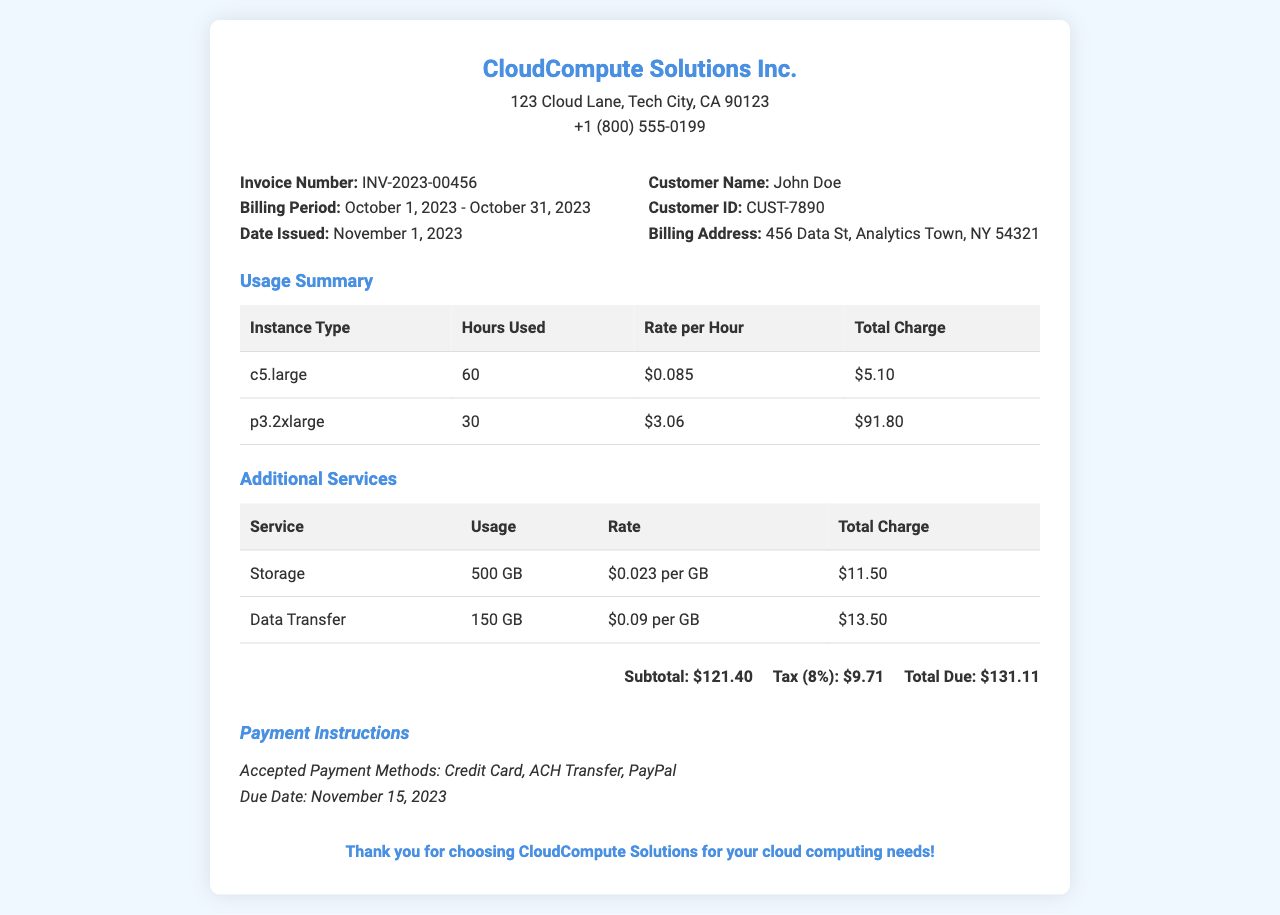what is the invoice number? The invoice number is found in the invoice details section of the document.
Answer: INV-2023-00456 who is the customer? The customer's name is specified in the invoice details section.
Answer: John Doe what is the billing period? The billing period describes the timeframe for which services were billed, found in the invoice details.
Answer: October 1, 2023 - October 31, 2023 how many hours were used for the p3.2xlarge instance? The hours used for the p3.2xlarge instance is listed in the usage summary section.
Answer: 30 what is the subtotal amount? The subtotal is summarized at the end of the calculations in the document.
Answer: $121.40 what is the total due? The total due is the final amount that needs to be paid, stated in the total section.
Answer: $131.11 what is the additional charge for data transfer? The total charge for data transfer is provided in the additional services section.
Answer: $13.50 when is the due date for payment? The due date for payment is specified in the payment instructions section.
Answer: November 15, 2023 how much was charged per GB for storage? The rate for storage per GB is indicated in the additional services table.
Answer: $0.023 per GB 